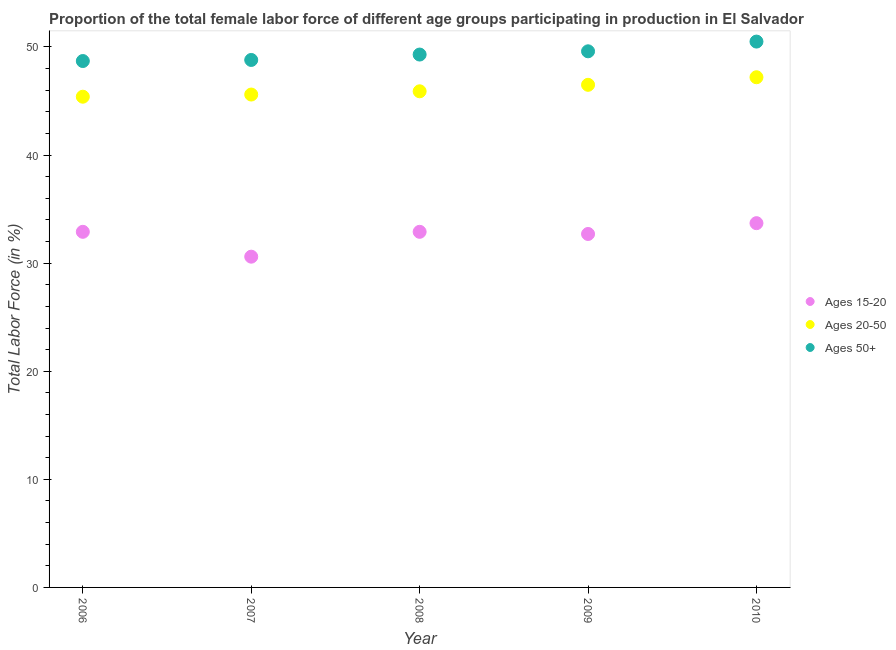Is the number of dotlines equal to the number of legend labels?
Your answer should be compact. Yes. What is the percentage of female labor force within the age group 20-50 in 2010?
Provide a short and direct response. 47.2. Across all years, what is the maximum percentage of female labor force within the age group 20-50?
Provide a succinct answer. 47.2. Across all years, what is the minimum percentage of female labor force within the age group 15-20?
Provide a succinct answer. 30.6. In which year was the percentage of female labor force above age 50 maximum?
Your response must be concise. 2010. In which year was the percentage of female labor force within the age group 20-50 minimum?
Offer a very short reply. 2006. What is the total percentage of female labor force within the age group 15-20 in the graph?
Your answer should be compact. 162.8. What is the difference between the percentage of female labor force within the age group 20-50 in 2007 and that in 2009?
Your answer should be very brief. -0.9. What is the difference between the percentage of female labor force above age 50 in 2009 and the percentage of female labor force within the age group 15-20 in 2008?
Provide a short and direct response. 16.7. What is the average percentage of female labor force within the age group 20-50 per year?
Your answer should be compact. 46.12. In the year 2007, what is the difference between the percentage of female labor force within the age group 20-50 and percentage of female labor force within the age group 15-20?
Your answer should be compact. 15. Is the difference between the percentage of female labor force above age 50 in 2008 and 2009 greater than the difference between the percentage of female labor force within the age group 20-50 in 2008 and 2009?
Give a very brief answer. Yes. What is the difference between the highest and the second highest percentage of female labor force within the age group 20-50?
Your answer should be compact. 0.7. What is the difference between the highest and the lowest percentage of female labor force within the age group 20-50?
Offer a terse response. 1.8. Is it the case that in every year, the sum of the percentage of female labor force within the age group 15-20 and percentage of female labor force within the age group 20-50 is greater than the percentage of female labor force above age 50?
Offer a very short reply. Yes. How many dotlines are there?
Your answer should be very brief. 3. How many years are there in the graph?
Make the answer very short. 5. What is the difference between two consecutive major ticks on the Y-axis?
Your response must be concise. 10. Are the values on the major ticks of Y-axis written in scientific E-notation?
Your answer should be compact. No. Where does the legend appear in the graph?
Your answer should be very brief. Center right. How many legend labels are there?
Provide a succinct answer. 3. What is the title of the graph?
Your response must be concise. Proportion of the total female labor force of different age groups participating in production in El Salvador. Does "Financial account" appear as one of the legend labels in the graph?
Your response must be concise. No. What is the label or title of the Y-axis?
Make the answer very short. Total Labor Force (in %). What is the Total Labor Force (in %) of Ages 15-20 in 2006?
Your answer should be compact. 32.9. What is the Total Labor Force (in %) in Ages 20-50 in 2006?
Provide a succinct answer. 45.4. What is the Total Labor Force (in %) of Ages 50+ in 2006?
Your response must be concise. 48.7. What is the Total Labor Force (in %) of Ages 15-20 in 2007?
Give a very brief answer. 30.6. What is the Total Labor Force (in %) of Ages 20-50 in 2007?
Keep it short and to the point. 45.6. What is the Total Labor Force (in %) in Ages 50+ in 2007?
Your response must be concise. 48.8. What is the Total Labor Force (in %) in Ages 15-20 in 2008?
Make the answer very short. 32.9. What is the Total Labor Force (in %) in Ages 20-50 in 2008?
Your response must be concise. 45.9. What is the Total Labor Force (in %) of Ages 50+ in 2008?
Provide a short and direct response. 49.3. What is the Total Labor Force (in %) of Ages 15-20 in 2009?
Your answer should be very brief. 32.7. What is the Total Labor Force (in %) in Ages 20-50 in 2009?
Provide a short and direct response. 46.5. What is the Total Labor Force (in %) of Ages 50+ in 2009?
Give a very brief answer. 49.6. What is the Total Labor Force (in %) of Ages 15-20 in 2010?
Keep it short and to the point. 33.7. What is the Total Labor Force (in %) of Ages 20-50 in 2010?
Ensure brevity in your answer.  47.2. What is the Total Labor Force (in %) of Ages 50+ in 2010?
Your answer should be compact. 50.5. Across all years, what is the maximum Total Labor Force (in %) in Ages 15-20?
Offer a terse response. 33.7. Across all years, what is the maximum Total Labor Force (in %) in Ages 20-50?
Keep it short and to the point. 47.2. Across all years, what is the maximum Total Labor Force (in %) of Ages 50+?
Your answer should be compact. 50.5. Across all years, what is the minimum Total Labor Force (in %) of Ages 15-20?
Make the answer very short. 30.6. Across all years, what is the minimum Total Labor Force (in %) of Ages 20-50?
Provide a short and direct response. 45.4. Across all years, what is the minimum Total Labor Force (in %) in Ages 50+?
Provide a succinct answer. 48.7. What is the total Total Labor Force (in %) of Ages 15-20 in the graph?
Ensure brevity in your answer.  162.8. What is the total Total Labor Force (in %) of Ages 20-50 in the graph?
Your answer should be very brief. 230.6. What is the total Total Labor Force (in %) of Ages 50+ in the graph?
Your response must be concise. 246.9. What is the difference between the Total Labor Force (in %) of Ages 15-20 in 2006 and that in 2007?
Offer a terse response. 2.3. What is the difference between the Total Labor Force (in %) in Ages 20-50 in 2006 and that in 2007?
Provide a short and direct response. -0.2. What is the difference between the Total Labor Force (in %) of Ages 20-50 in 2006 and that in 2008?
Keep it short and to the point. -0.5. What is the difference between the Total Labor Force (in %) in Ages 50+ in 2006 and that in 2009?
Your answer should be very brief. -0.9. What is the difference between the Total Labor Force (in %) of Ages 15-20 in 2007 and that in 2008?
Offer a very short reply. -2.3. What is the difference between the Total Labor Force (in %) in Ages 20-50 in 2007 and that in 2008?
Make the answer very short. -0.3. What is the difference between the Total Labor Force (in %) of Ages 15-20 in 2007 and that in 2009?
Your answer should be very brief. -2.1. What is the difference between the Total Labor Force (in %) of Ages 20-50 in 2007 and that in 2009?
Your response must be concise. -0.9. What is the difference between the Total Labor Force (in %) in Ages 50+ in 2007 and that in 2009?
Make the answer very short. -0.8. What is the difference between the Total Labor Force (in %) of Ages 20-50 in 2007 and that in 2010?
Offer a very short reply. -1.6. What is the difference between the Total Labor Force (in %) in Ages 50+ in 2007 and that in 2010?
Ensure brevity in your answer.  -1.7. What is the difference between the Total Labor Force (in %) of Ages 20-50 in 2008 and that in 2009?
Make the answer very short. -0.6. What is the difference between the Total Labor Force (in %) of Ages 15-20 in 2008 and that in 2010?
Your response must be concise. -0.8. What is the difference between the Total Labor Force (in %) in Ages 20-50 in 2008 and that in 2010?
Your answer should be compact. -1.3. What is the difference between the Total Labor Force (in %) of Ages 15-20 in 2009 and that in 2010?
Make the answer very short. -1. What is the difference between the Total Labor Force (in %) in Ages 20-50 in 2009 and that in 2010?
Your answer should be compact. -0.7. What is the difference between the Total Labor Force (in %) in Ages 15-20 in 2006 and the Total Labor Force (in %) in Ages 20-50 in 2007?
Make the answer very short. -12.7. What is the difference between the Total Labor Force (in %) of Ages 15-20 in 2006 and the Total Labor Force (in %) of Ages 50+ in 2007?
Your answer should be very brief. -15.9. What is the difference between the Total Labor Force (in %) in Ages 15-20 in 2006 and the Total Labor Force (in %) in Ages 50+ in 2008?
Offer a very short reply. -16.4. What is the difference between the Total Labor Force (in %) of Ages 15-20 in 2006 and the Total Labor Force (in %) of Ages 20-50 in 2009?
Your answer should be very brief. -13.6. What is the difference between the Total Labor Force (in %) of Ages 15-20 in 2006 and the Total Labor Force (in %) of Ages 50+ in 2009?
Provide a succinct answer. -16.7. What is the difference between the Total Labor Force (in %) of Ages 15-20 in 2006 and the Total Labor Force (in %) of Ages 20-50 in 2010?
Offer a terse response. -14.3. What is the difference between the Total Labor Force (in %) of Ages 15-20 in 2006 and the Total Labor Force (in %) of Ages 50+ in 2010?
Provide a succinct answer. -17.6. What is the difference between the Total Labor Force (in %) of Ages 20-50 in 2006 and the Total Labor Force (in %) of Ages 50+ in 2010?
Offer a very short reply. -5.1. What is the difference between the Total Labor Force (in %) of Ages 15-20 in 2007 and the Total Labor Force (in %) of Ages 20-50 in 2008?
Your response must be concise. -15.3. What is the difference between the Total Labor Force (in %) of Ages 15-20 in 2007 and the Total Labor Force (in %) of Ages 50+ in 2008?
Your answer should be compact. -18.7. What is the difference between the Total Labor Force (in %) in Ages 20-50 in 2007 and the Total Labor Force (in %) in Ages 50+ in 2008?
Give a very brief answer. -3.7. What is the difference between the Total Labor Force (in %) of Ages 15-20 in 2007 and the Total Labor Force (in %) of Ages 20-50 in 2009?
Give a very brief answer. -15.9. What is the difference between the Total Labor Force (in %) of Ages 15-20 in 2007 and the Total Labor Force (in %) of Ages 50+ in 2009?
Ensure brevity in your answer.  -19. What is the difference between the Total Labor Force (in %) in Ages 20-50 in 2007 and the Total Labor Force (in %) in Ages 50+ in 2009?
Your answer should be compact. -4. What is the difference between the Total Labor Force (in %) of Ages 15-20 in 2007 and the Total Labor Force (in %) of Ages 20-50 in 2010?
Your answer should be compact. -16.6. What is the difference between the Total Labor Force (in %) in Ages 15-20 in 2007 and the Total Labor Force (in %) in Ages 50+ in 2010?
Ensure brevity in your answer.  -19.9. What is the difference between the Total Labor Force (in %) in Ages 15-20 in 2008 and the Total Labor Force (in %) in Ages 50+ in 2009?
Offer a terse response. -16.7. What is the difference between the Total Labor Force (in %) of Ages 20-50 in 2008 and the Total Labor Force (in %) of Ages 50+ in 2009?
Keep it short and to the point. -3.7. What is the difference between the Total Labor Force (in %) in Ages 15-20 in 2008 and the Total Labor Force (in %) in Ages 20-50 in 2010?
Your answer should be very brief. -14.3. What is the difference between the Total Labor Force (in %) in Ages 15-20 in 2008 and the Total Labor Force (in %) in Ages 50+ in 2010?
Offer a very short reply. -17.6. What is the difference between the Total Labor Force (in %) in Ages 15-20 in 2009 and the Total Labor Force (in %) in Ages 20-50 in 2010?
Your answer should be very brief. -14.5. What is the difference between the Total Labor Force (in %) of Ages 15-20 in 2009 and the Total Labor Force (in %) of Ages 50+ in 2010?
Keep it short and to the point. -17.8. What is the difference between the Total Labor Force (in %) of Ages 20-50 in 2009 and the Total Labor Force (in %) of Ages 50+ in 2010?
Ensure brevity in your answer.  -4. What is the average Total Labor Force (in %) in Ages 15-20 per year?
Your answer should be compact. 32.56. What is the average Total Labor Force (in %) of Ages 20-50 per year?
Ensure brevity in your answer.  46.12. What is the average Total Labor Force (in %) of Ages 50+ per year?
Keep it short and to the point. 49.38. In the year 2006, what is the difference between the Total Labor Force (in %) in Ages 15-20 and Total Labor Force (in %) in Ages 20-50?
Make the answer very short. -12.5. In the year 2006, what is the difference between the Total Labor Force (in %) in Ages 15-20 and Total Labor Force (in %) in Ages 50+?
Offer a very short reply. -15.8. In the year 2007, what is the difference between the Total Labor Force (in %) in Ages 15-20 and Total Labor Force (in %) in Ages 50+?
Your answer should be very brief. -18.2. In the year 2008, what is the difference between the Total Labor Force (in %) in Ages 15-20 and Total Labor Force (in %) in Ages 50+?
Keep it short and to the point. -16.4. In the year 2008, what is the difference between the Total Labor Force (in %) in Ages 20-50 and Total Labor Force (in %) in Ages 50+?
Make the answer very short. -3.4. In the year 2009, what is the difference between the Total Labor Force (in %) of Ages 15-20 and Total Labor Force (in %) of Ages 20-50?
Your response must be concise. -13.8. In the year 2009, what is the difference between the Total Labor Force (in %) of Ages 15-20 and Total Labor Force (in %) of Ages 50+?
Give a very brief answer. -16.9. In the year 2009, what is the difference between the Total Labor Force (in %) in Ages 20-50 and Total Labor Force (in %) in Ages 50+?
Your answer should be very brief. -3.1. In the year 2010, what is the difference between the Total Labor Force (in %) in Ages 15-20 and Total Labor Force (in %) in Ages 20-50?
Ensure brevity in your answer.  -13.5. In the year 2010, what is the difference between the Total Labor Force (in %) of Ages 15-20 and Total Labor Force (in %) of Ages 50+?
Keep it short and to the point. -16.8. What is the ratio of the Total Labor Force (in %) in Ages 15-20 in 2006 to that in 2007?
Your answer should be compact. 1.08. What is the ratio of the Total Labor Force (in %) of Ages 20-50 in 2006 to that in 2007?
Your answer should be very brief. 1. What is the ratio of the Total Labor Force (in %) of Ages 15-20 in 2006 to that in 2008?
Keep it short and to the point. 1. What is the ratio of the Total Labor Force (in %) in Ages 20-50 in 2006 to that in 2008?
Provide a succinct answer. 0.99. What is the ratio of the Total Labor Force (in %) of Ages 50+ in 2006 to that in 2008?
Make the answer very short. 0.99. What is the ratio of the Total Labor Force (in %) of Ages 20-50 in 2006 to that in 2009?
Make the answer very short. 0.98. What is the ratio of the Total Labor Force (in %) of Ages 50+ in 2006 to that in 2009?
Ensure brevity in your answer.  0.98. What is the ratio of the Total Labor Force (in %) in Ages 15-20 in 2006 to that in 2010?
Keep it short and to the point. 0.98. What is the ratio of the Total Labor Force (in %) of Ages 20-50 in 2006 to that in 2010?
Provide a succinct answer. 0.96. What is the ratio of the Total Labor Force (in %) of Ages 50+ in 2006 to that in 2010?
Give a very brief answer. 0.96. What is the ratio of the Total Labor Force (in %) of Ages 15-20 in 2007 to that in 2008?
Your response must be concise. 0.93. What is the ratio of the Total Labor Force (in %) of Ages 50+ in 2007 to that in 2008?
Ensure brevity in your answer.  0.99. What is the ratio of the Total Labor Force (in %) of Ages 15-20 in 2007 to that in 2009?
Your answer should be very brief. 0.94. What is the ratio of the Total Labor Force (in %) of Ages 20-50 in 2007 to that in 2009?
Provide a short and direct response. 0.98. What is the ratio of the Total Labor Force (in %) of Ages 50+ in 2007 to that in 2009?
Offer a very short reply. 0.98. What is the ratio of the Total Labor Force (in %) in Ages 15-20 in 2007 to that in 2010?
Offer a very short reply. 0.91. What is the ratio of the Total Labor Force (in %) of Ages 20-50 in 2007 to that in 2010?
Ensure brevity in your answer.  0.97. What is the ratio of the Total Labor Force (in %) in Ages 50+ in 2007 to that in 2010?
Give a very brief answer. 0.97. What is the ratio of the Total Labor Force (in %) in Ages 15-20 in 2008 to that in 2009?
Provide a short and direct response. 1.01. What is the ratio of the Total Labor Force (in %) in Ages 20-50 in 2008 to that in 2009?
Give a very brief answer. 0.99. What is the ratio of the Total Labor Force (in %) of Ages 15-20 in 2008 to that in 2010?
Make the answer very short. 0.98. What is the ratio of the Total Labor Force (in %) in Ages 20-50 in 2008 to that in 2010?
Your answer should be compact. 0.97. What is the ratio of the Total Labor Force (in %) of Ages 50+ in 2008 to that in 2010?
Provide a short and direct response. 0.98. What is the ratio of the Total Labor Force (in %) in Ages 15-20 in 2009 to that in 2010?
Keep it short and to the point. 0.97. What is the ratio of the Total Labor Force (in %) in Ages 20-50 in 2009 to that in 2010?
Provide a succinct answer. 0.99. What is the ratio of the Total Labor Force (in %) of Ages 50+ in 2009 to that in 2010?
Provide a succinct answer. 0.98. What is the difference between the highest and the second highest Total Labor Force (in %) in Ages 15-20?
Offer a very short reply. 0.8. What is the difference between the highest and the second highest Total Labor Force (in %) of Ages 50+?
Keep it short and to the point. 0.9. What is the difference between the highest and the lowest Total Labor Force (in %) of Ages 15-20?
Your answer should be very brief. 3.1. What is the difference between the highest and the lowest Total Labor Force (in %) in Ages 50+?
Provide a succinct answer. 1.8. 